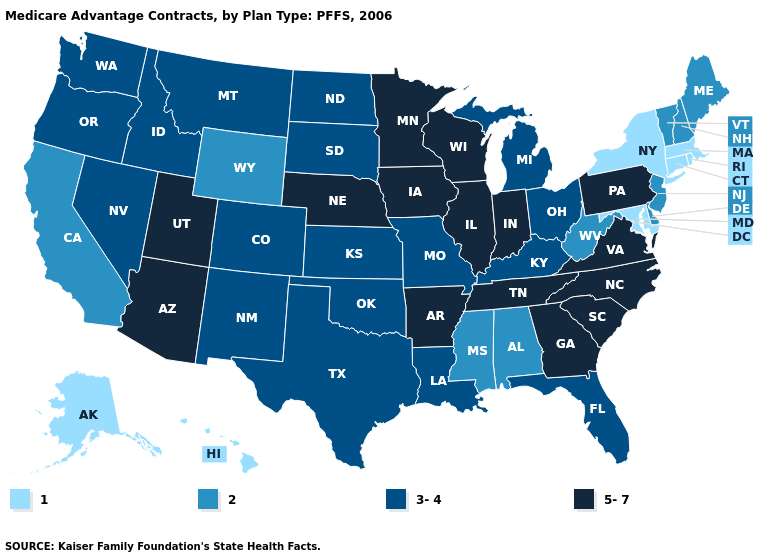Among the states that border Rhode Island , which have the highest value?
Concise answer only. Connecticut, Massachusetts. What is the value of Nebraska?
Answer briefly. 5-7. Which states hav the highest value in the South?
Be succinct. Arkansas, Georgia, North Carolina, South Carolina, Tennessee, Virginia. Name the states that have a value in the range 3-4?
Concise answer only. Colorado, Florida, Idaho, Kansas, Kentucky, Louisiana, Michigan, Missouri, Montana, North Dakota, New Mexico, Nevada, Ohio, Oklahoma, Oregon, South Dakota, Texas, Washington. Is the legend a continuous bar?
Quick response, please. No. Does South Carolina have the highest value in the USA?
Quick response, please. Yes. Which states have the lowest value in the MidWest?
Answer briefly. Kansas, Michigan, Missouri, North Dakota, Ohio, South Dakota. What is the lowest value in the MidWest?
Answer briefly. 3-4. What is the value of Louisiana?
Be succinct. 3-4. Does New York have the lowest value in the Northeast?
Answer briefly. Yes. Which states hav the highest value in the Northeast?
Be succinct. Pennsylvania. Name the states that have a value in the range 1?
Give a very brief answer. Alaska, Connecticut, Hawaii, Massachusetts, Maryland, New York, Rhode Island. What is the value of Iowa?
Keep it brief. 5-7. Name the states that have a value in the range 1?
Be succinct. Alaska, Connecticut, Hawaii, Massachusetts, Maryland, New York, Rhode Island. Name the states that have a value in the range 3-4?
Short answer required. Colorado, Florida, Idaho, Kansas, Kentucky, Louisiana, Michigan, Missouri, Montana, North Dakota, New Mexico, Nevada, Ohio, Oklahoma, Oregon, South Dakota, Texas, Washington. 